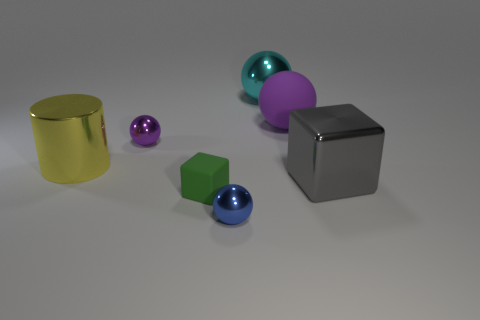Is the number of green blocks behind the small purple object the same as the number of small green rubber blocks to the right of the large matte object?
Provide a short and direct response. Yes. Are there any big cyan spheres that are on the left side of the metal sphere in front of the cylinder?
Your answer should be compact. No. The blue object is what shape?
Make the answer very short. Sphere. The metallic object that is the same color as the large matte object is what size?
Your answer should be compact. Small. What size is the rubber object in front of the small metal object behind the small rubber thing?
Make the answer very short. Small. There is a thing behind the large rubber thing; how big is it?
Give a very brief answer. Large. Is the number of small purple shiny things behind the tiny green block less than the number of tiny purple metallic balls that are on the left side of the blue shiny ball?
Ensure brevity in your answer.  No. The shiny cylinder is what color?
Provide a succinct answer. Yellow. Is there another large metallic block of the same color as the large cube?
Keep it short and to the point. No. There is a small object in front of the block on the left side of the metal sphere that is in front of the tiny purple sphere; what shape is it?
Provide a succinct answer. Sphere. 